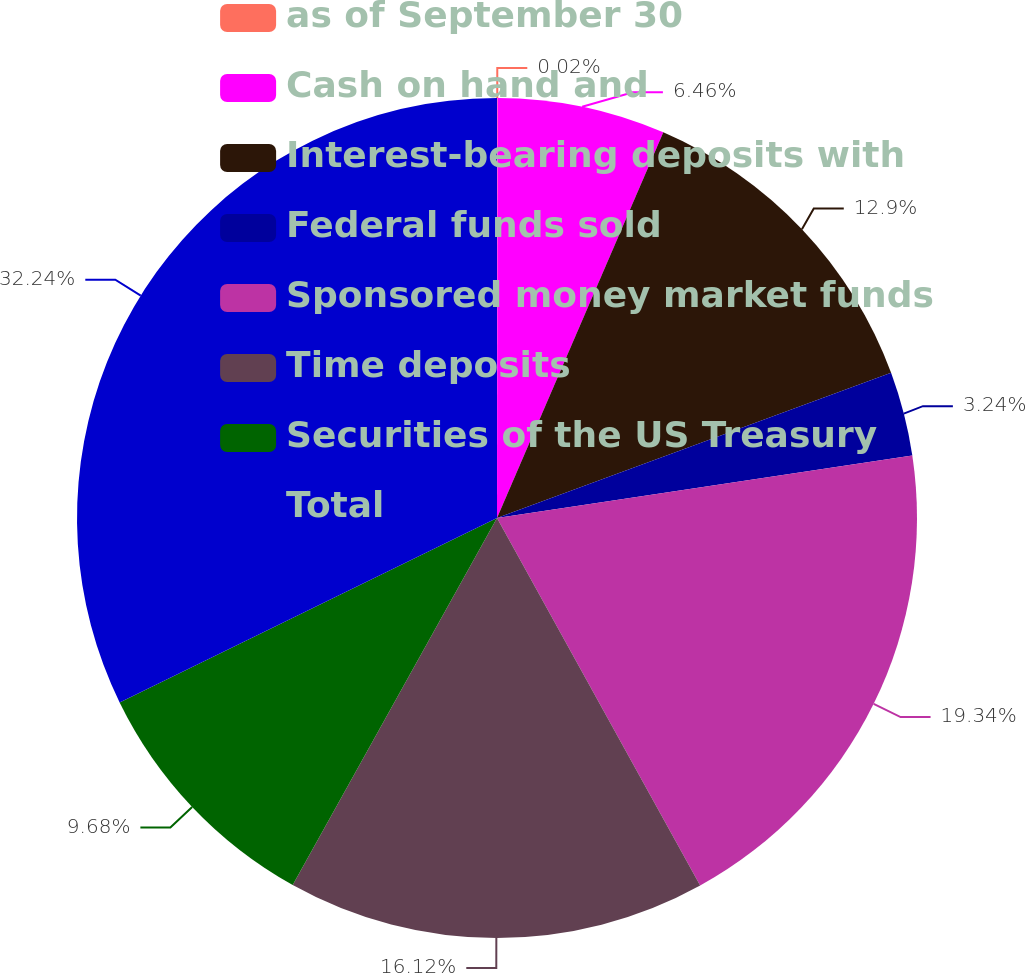<chart> <loc_0><loc_0><loc_500><loc_500><pie_chart><fcel>as of September 30<fcel>Cash on hand and<fcel>Interest-bearing deposits with<fcel>Federal funds sold<fcel>Sponsored money market funds<fcel>Time deposits<fcel>Securities of the US Treasury<fcel>Total<nl><fcel>0.02%<fcel>6.46%<fcel>12.9%<fcel>3.24%<fcel>19.34%<fcel>16.12%<fcel>9.68%<fcel>32.23%<nl></chart> 